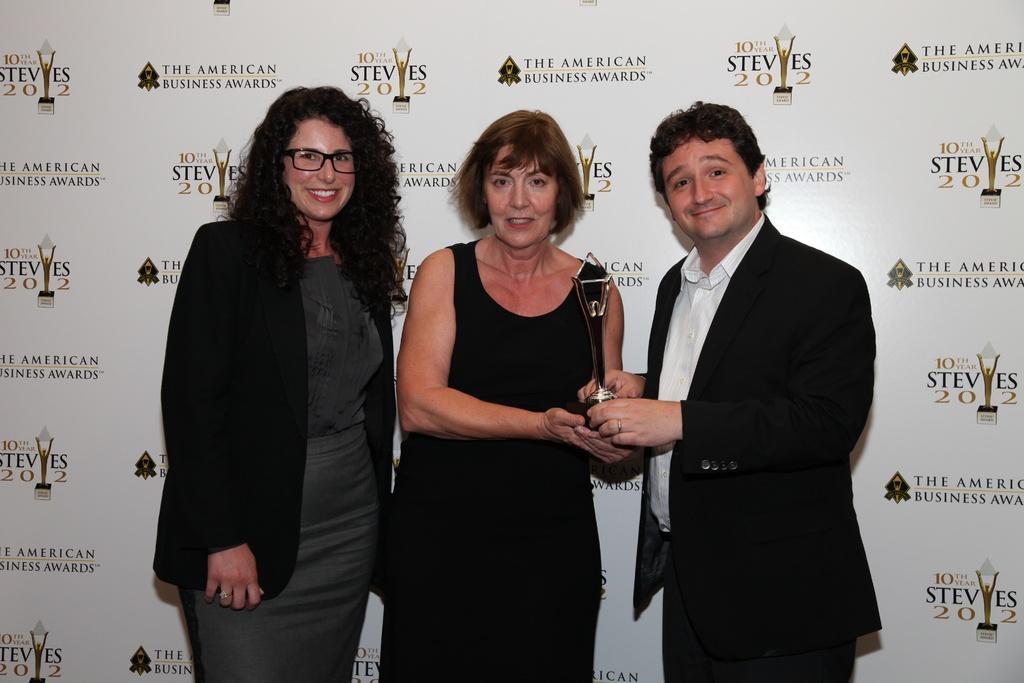Please provide a concise description of this image. In this image we can see three persons, one of them is holding a trophy, behind them there is a board with text and image on it. 